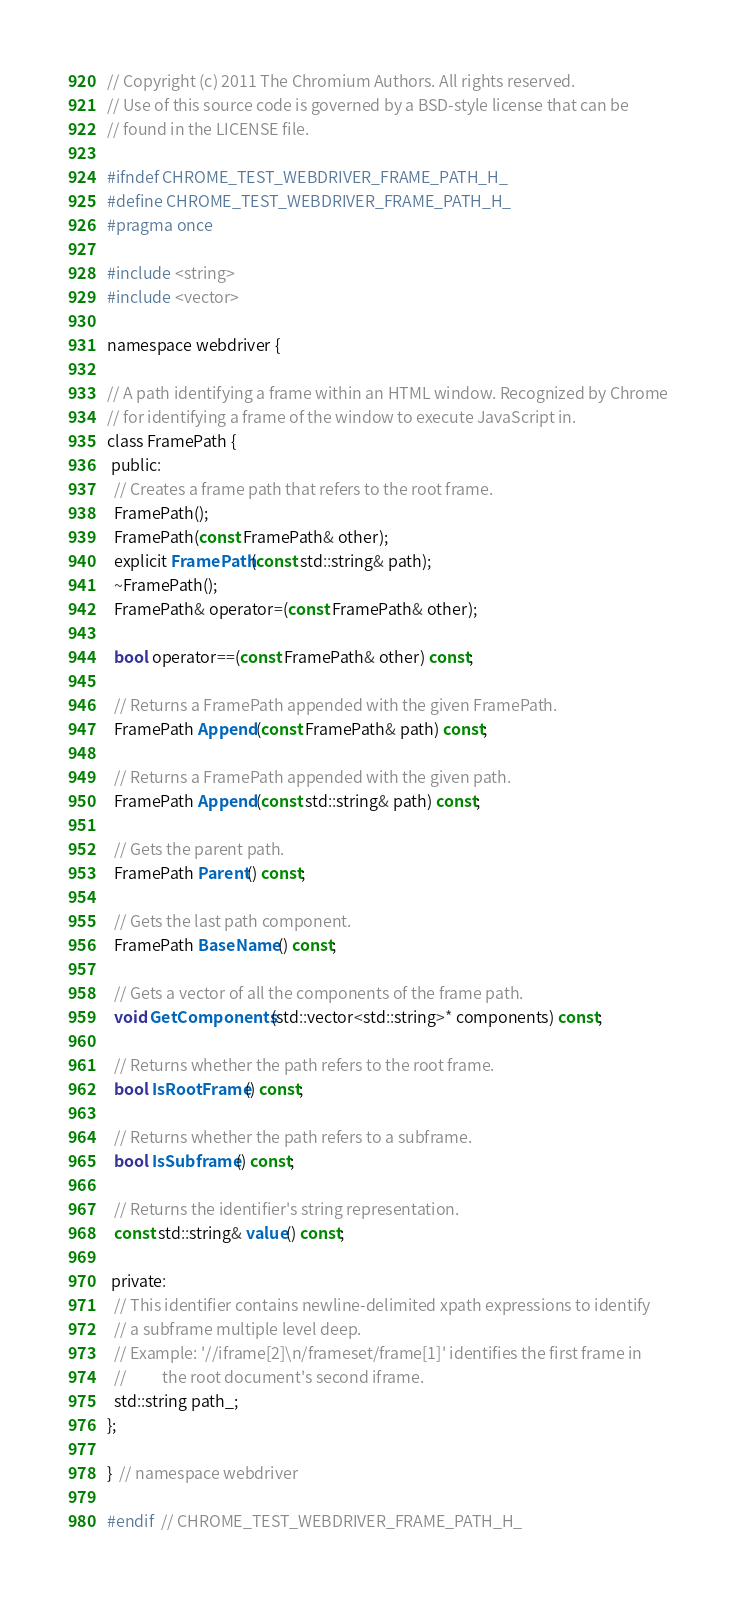<code> <loc_0><loc_0><loc_500><loc_500><_C_>// Copyright (c) 2011 The Chromium Authors. All rights reserved.
// Use of this source code is governed by a BSD-style license that can be
// found in the LICENSE file.

#ifndef CHROME_TEST_WEBDRIVER_FRAME_PATH_H_
#define CHROME_TEST_WEBDRIVER_FRAME_PATH_H_
#pragma once

#include <string>
#include <vector>

namespace webdriver {

// A path identifying a frame within an HTML window. Recognized by Chrome
// for identifying a frame of the window to execute JavaScript in.
class FramePath {
 public:
  // Creates a frame path that refers to the root frame.
  FramePath();
  FramePath(const FramePath& other);
  explicit FramePath(const std::string& path);
  ~FramePath();
  FramePath& operator=(const FramePath& other);

  bool operator==(const FramePath& other) const;

  // Returns a FramePath appended with the given FramePath.
  FramePath Append(const FramePath& path) const;

  // Returns a FramePath appended with the given path.
  FramePath Append(const std::string& path) const;

  // Gets the parent path.
  FramePath Parent() const;

  // Gets the last path component.
  FramePath BaseName() const;

  // Gets a vector of all the components of the frame path.
  void GetComponents(std::vector<std::string>* components) const;

  // Returns whether the path refers to the root frame.
  bool IsRootFrame() const;

  // Returns whether the path refers to a subframe.
  bool IsSubframe() const;

  // Returns the identifier's string representation.
  const std::string& value() const;

 private:
  // This identifier contains newline-delimited xpath expressions to identify
  // a subframe multiple level deep.
  // Example: '//iframe[2]\n/frameset/frame[1]' identifies the first frame in
  //          the root document's second iframe.
  std::string path_;
};

}  // namespace webdriver

#endif  // CHROME_TEST_WEBDRIVER_FRAME_PATH_H_
</code> 